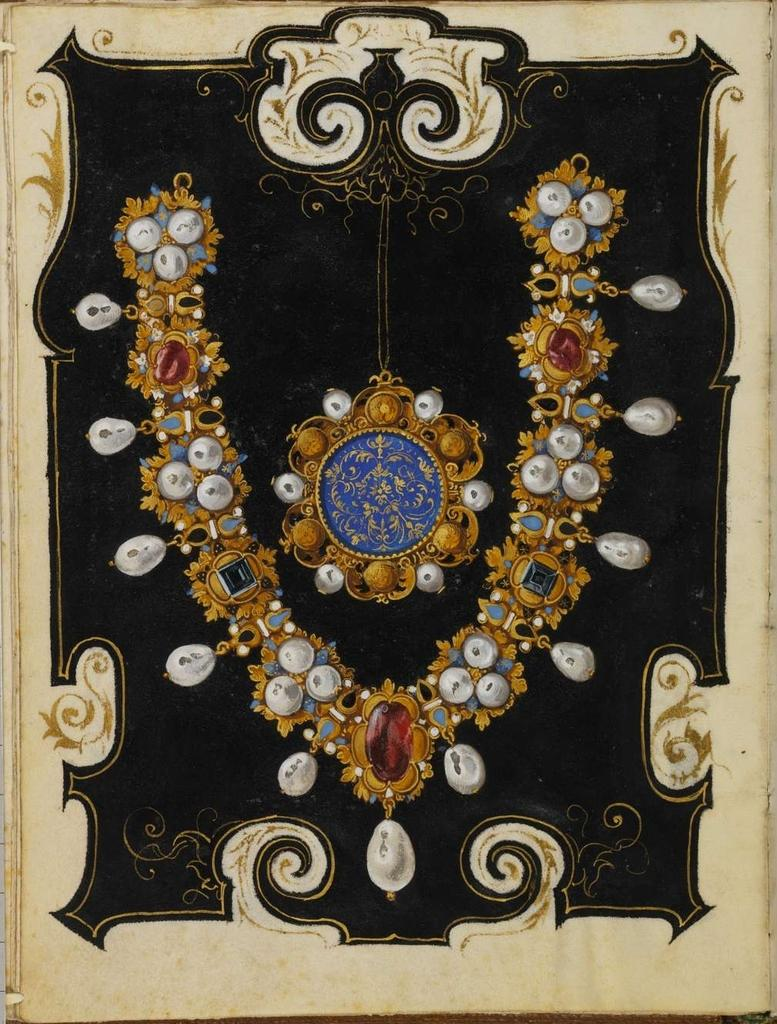What type of artwork is shown in the image? The image is a painting. What is the main subject of the painting? The painting depicts ornaments. What colors are the jewels on the ornaments? The jewels on the ornaments have white, red, and green colors. Can you see a mountain in the background of the painting? There is no mountain visible in the painting; it focuses on the ornaments with jewels. Is there an oven depicted in the painting? There is no oven present in the painting; it features ornaments with jewels. 